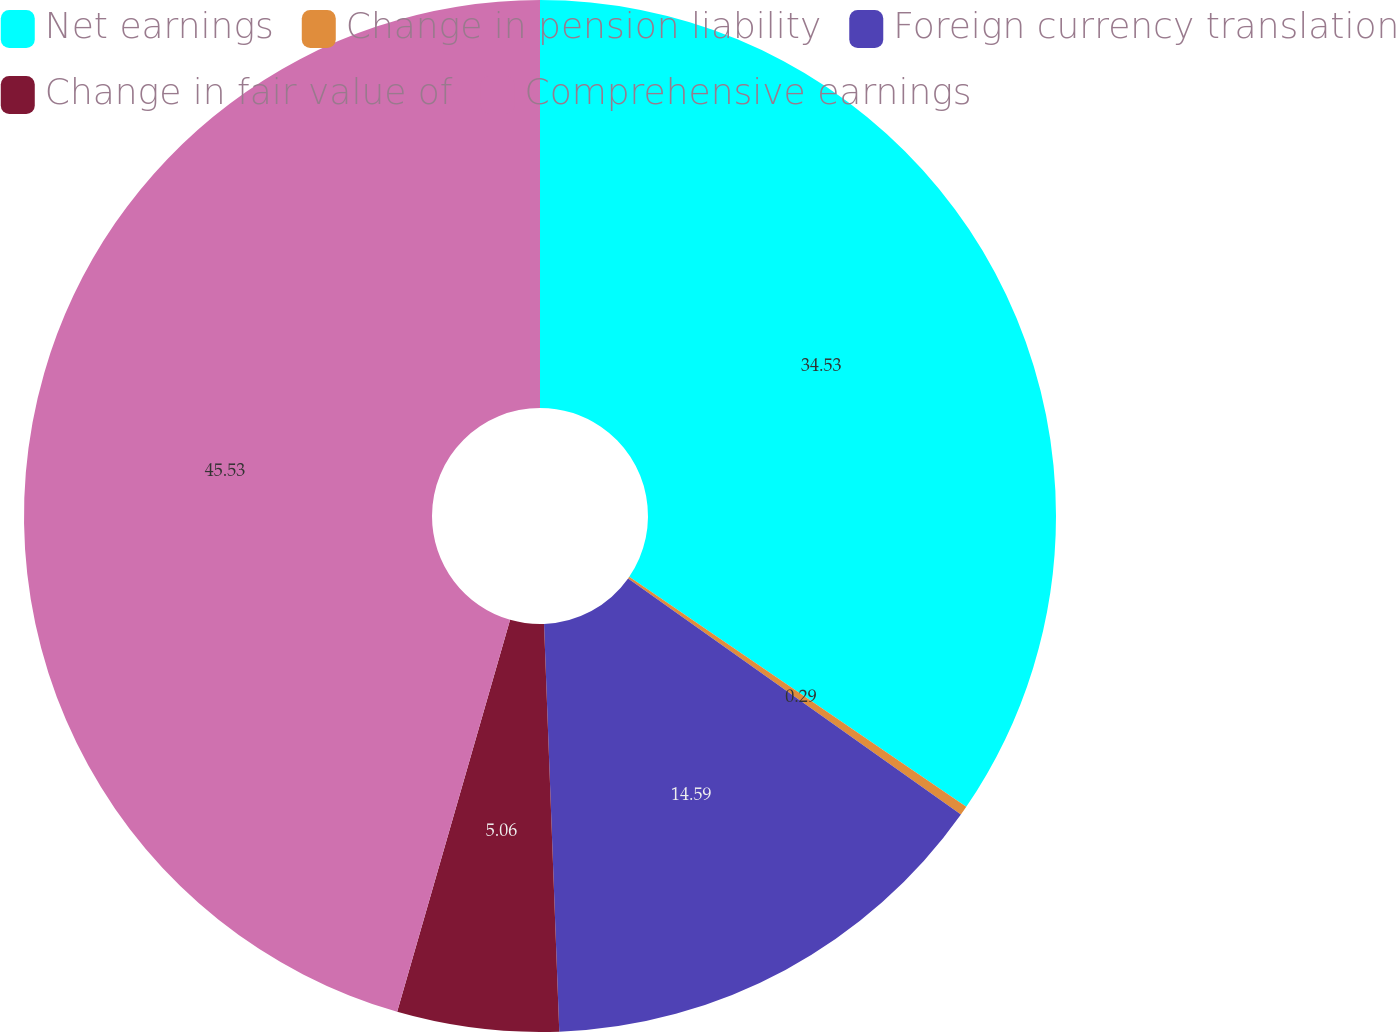Convert chart. <chart><loc_0><loc_0><loc_500><loc_500><pie_chart><fcel>Net earnings<fcel>Change in pension liability<fcel>Foreign currency translation<fcel>Change in fair value of<fcel>Comprehensive earnings<nl><fcel>34.53%<fcel>0.29%<fcel>14.59%<fcel>5.06%<fcel>45.54%<nl></chart> 